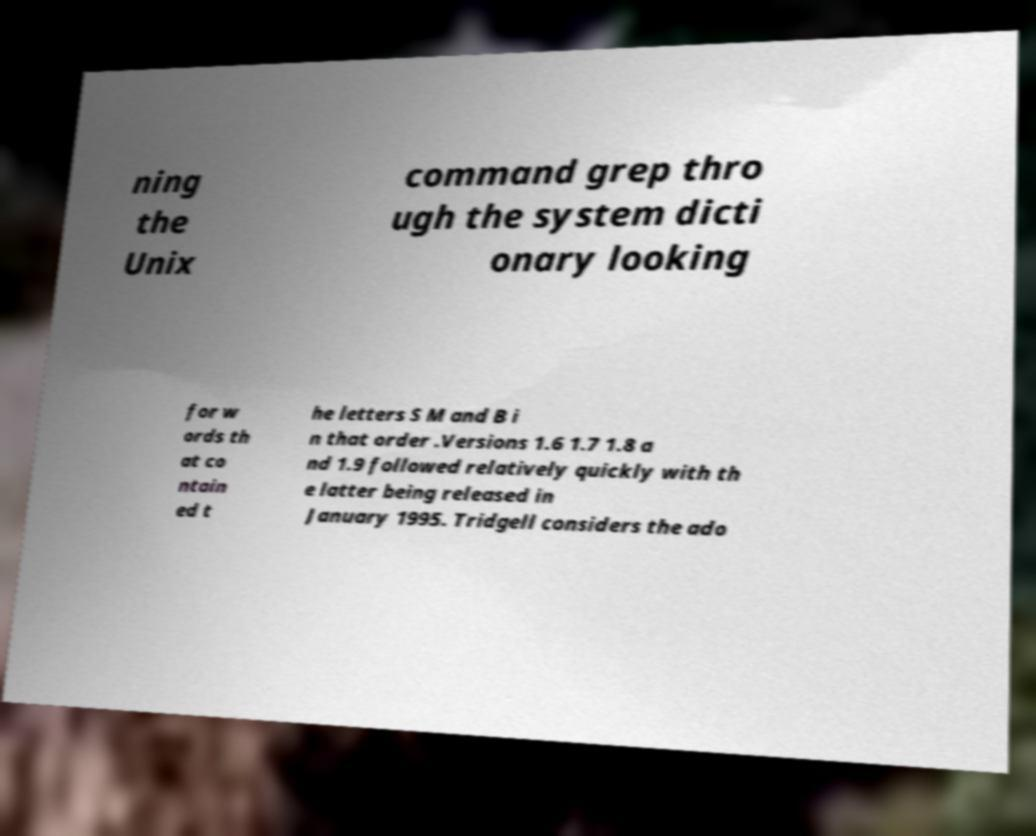Please read and relay the text visible in this image. What does it say? ning the Unix command grep thro ugh the system dicti onary looking for w ords th at co ntain ed t he letters S M and B i n that order .Versions 1.6 1.7 1.8 a nd 1.9 followed relatively quickly with th e latter being released in January 1995. Tridgell considers the ado 